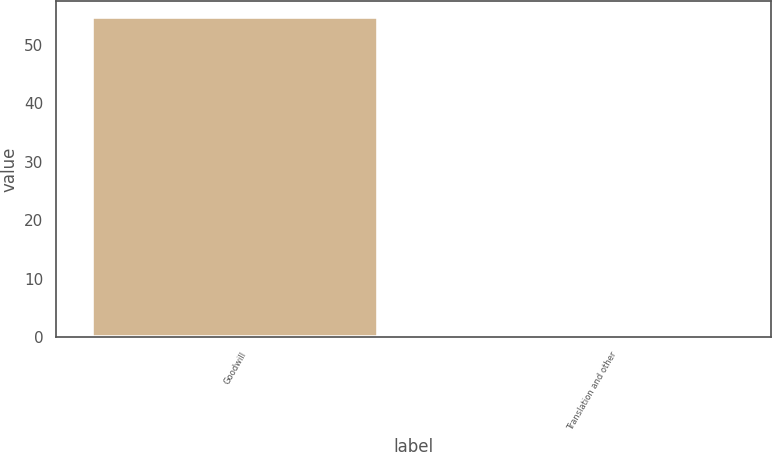<chart> <loc_0><loc_0><loc_500><loc_500><bar_chart><fcel>Goodwill<fcel>Translation and other<nl><fcel>54.8<fcel>0.3<nl></chart> 